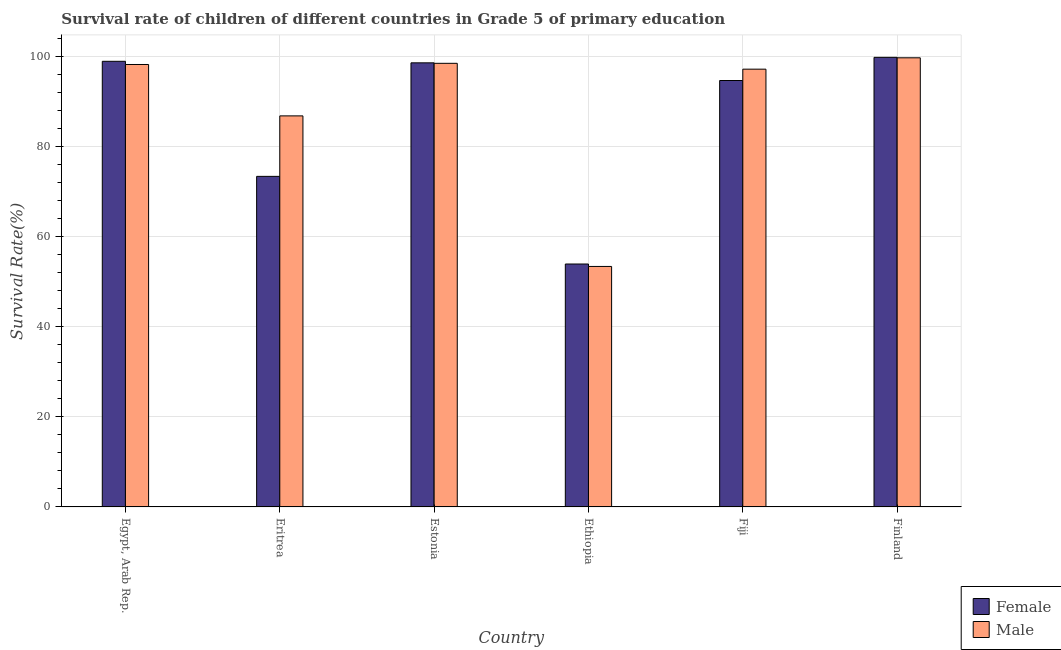How many different coloured bars are there?
Make the answer very short. 2. How many groups of bars are there?
Provide a short and direct response. 6. Are the number of bars per tick equal to the number of legend labels?
Your response must be concise. Yes. Are the number of bars on each tick of the X-axis equal?
Offer a very short reply. Yes. What is the survival rate of male students in primary education in Eritrea?
Ensure brevity in your answer.  86.85. Across all countries, what is the maximum survival rate of female students in primary education?
Your answer should be very brief. 99.85. Across all countries, what is the minimum survival rate of female students in primary education?
Give a very brief answer. 53.95. In which country was the survival rate of male students in primary education maximum?
Your response must be concise. Finland. In which country was the survival rate of female students in primary education minimum?
Give a very brief answer. Ethiopia. What is the total survival rate of female students in primary education in the graph?
Keep it short and to the point. 519.52. What is the difference between the survival rate of male students in primary education in Egypt, Arab Rep. and that in Fiji?
Provide a succinct answer. 1.04. What is the difference between the survival rate of male students in primary education in Finland and the survival rate of female students in primary education in Eritrea?
Offer a very short reply. 26.33. What is the average survival rate of female students in primary education per country?
Keep it short and to the point. 86.59. What is the difference between the survival rate of female students in primary education and survival rate of male students in primary education in Estonia?
Keep it short and to the point. 0.11. What is the ratio of the survival rate of male students in primary education in Estonia to that in Fiji?
Keep it short and to the point. 1.01. Is the difference between the survival rate of male students in primary education in Egypt, Arab Rep. and Eritrea greater than the difference between the survival rate of female students in primary education in Egypt, Arab Rep. and Eritrea?
Your response must be concise. No. What is the difference between the highest and the second highest survival rate of male students in primary education?
Offer a very short reply. 1.23. What is the difference between the highest and the lowest survival rate of male students in primary education?
Make the answer very short. 46.34. Is the sum of the survival rate of male students in primary education in Ethiopia and Fiji greater than the maximum survival rate of female students in primary education across all countries?
Give a very brief answer. Yes. What does the 1st bar from the left in Egypt, Arab Rep. represents?
Offer a very short reply. Female. How many bars are there?
Provide a short and direct response. 12. Are the values on the major ticks of Y-axis written in scientific E-notation?
Ensure brevity in your answer.  No. How many legend labels are there?
Keep it short and to the point. 2. How are the legend labels stacked?
Offer a terse response. Vertical. What is the title of the graph?
Keep it short and to the point. Survival rate of children of different countries in Grade 5 of primary education. What is the label or title of the Y-axis?
Ensure brevity in your answer.  Survival Rate(%). What is the Survival Rate(%) in Female in Egypt, Arab Rep.?
Offer a very short reply. 98.97. What is the Survival Rate(%) in Male in Egypt, Arab Rep.?
Offer a terse response. 98.26. What is the Survival Rate(%) in Female in Eritrea?
Provide a short and direct response. 73.41. What is the Survival Rate(%) of Male in Eritrea?
Provide a succinct answer. 86.85. What is the Survival Rate(%) in Female in Estonia?
Ensure brevity in your answer.  98.63. What is the Survival Rate(%) of Male in Estonia?
Provide a succinct answer. 98.52. What is the Survival Rate(%) in Female in Ethiopia?
Keep it short and to the point. 53.95. What is the Survival Rate(%) of Male in Ethiopia?
Ensure brevity in your answer.  53.41. What is the Survival Rate(%) in Female in Fiji?
Your answer should be compact. 94.71. What is the Survival Rate(%) of Male in Fiji?
Your response must be concise. 97.22. What is the Survival Rate(%) in Female in Finland?
Offer a terse response. 99.85. What is the Survival Rate(%) in Male in Finland?
Provide a succinct answer. 99.75. Across all countries, what is the maximum Survival Rate(%) in Female?
Offer a very short reply. 99.85. Across all countries, what is the maximum Survival Rate(%) of Male?
Offer a very short reply. 99.75. Across all countries, what is the minimum Survival Rate(%) in Female?
Your answer should be very brief. 53.95. Across all countries, what is the minimum Survival Rate(%) of Male?
Ensure brevity in your answer.  53.41. What is the total Survival Rate(%) of Female in the graph?
Provide a short and direct response. 519.52. What is the total Survival Rate(%) in Male in the graph?
Provide a succinct answer. 534.02. What is the difference between the Survival Rate(%) of Female in Egypt, Arab Rep. and that in Eritrea?
Your answer should be very brief. 25.55. What is the difference between the Survival Rate(%) in Male in Egypt, Arab Rep. and that in Eritrea?
Provide a succinct answer. 11.41. What is the difference between the Survival Rate(%) of Female in Egypt, Arab Rep. and that in Estonia?
Your answer should be compact. 0.34. What is the difference between the Survival Rate(%) in Male in Egypt, Arab Rep. and that in Estonia?
Keep it short and to the point. -0.26. What is the difference between the Survival Rate(%) of Female in Egypt, Arab Rep. and that in Ethiopia?
Your response must be concise. 45.02. What is the difference between the Survival Rate(%) of Male in Egypt, Arab Rep. and that in Ethiopia?
Your answer should be very brief. 44.85. What is the difference between the Survival Rate(%) in Female in Egypt, Arab Rep. and that in Fiji?
Provide a short and direct response. 4.26. What is the difference between the Survival Rate(%) of Male in Egypt, Arab Rep. and that in Fiji?
Give a very brief answer. 1.04. What is the difference between the Survival Rate(%) of Female in Egypt, Arab Rep. and that in Finland?
Your response must be concise. -0.88. What is the difference between the Survival Rate(%) in Male in Egypt, Arab Rep. and that in Finland?
Offer a terse response. -1.49. What is the difference between the Survival Rate(%) of Female in Eritrea and that in Estonia?
Provide a short and direct response. -25.22. What is the difference between the Survival Rate(%) in Male in Eritrea and that in Estonia?
Ensure brevity in your answer.  -11.67. What is the difference between the Survival Rate(%) of Female in Eritrea and that in Ethiopia?
Provide a succinct answer. 19.46. What is the difference between the Survival Rate(%) in Male in Eritrea and that in Ethiopia?
Ensure brevity in your answer.  33.44. What is the difference between the Survival Rate(%) in Female in Eritrea and that in Fiji?
Make the answer very short. -21.29. What is the difference between the Survival Rate(%) of Male in Eritrea and that in Fiji?
Offer a very short reply. -10.37. What is the difference between the Survival Rate(%) in Female in Eritrea and that in Finland?
Offer a terse response. -26.43. What is the difference between the Survival Rate(%) of Male in Eritrea and that in Finland?
Offer a very short reply. -12.9. What is the difference between the Survival Rate(%) of Female in Estonia and that in Ethiopia?
Your response must be concise. 44.68. What is the difference between the Survival Rate(%) in Male in Estonia and that in Ethiopia?
Your answer should be very brief. 45.11. What is the difference between the Survival Rate(%) in Female in Estonia and that in Fiji?
Your answer should be very brief. 3.92. What is the difference between the Survival Rate(%) of Male in Estonia and that in Fiji?
Give a very brief answer. 1.3. What is the difference between the Survival Rate(%) in Female in Estonia and that in Finland?
Give a very brief answer. -1.22. What is the difference between the Survival Rate(%) of Male in Estonia and that in Finland?
Provide a succinct answer. -1.23. What is the difference between the Survival Rate(%) in Female in Ethiopia and that in Fiji?
Your answer should be very brief. -40.75. What is the difference between the Survival Rate(%) of Male in Ethiopia and that in Fiji?
Offer a terse response. -43.81. What is the difference between the Survival Rate(%) in Female in Ethiopia and that in Finland?
Ensure brevity in your answer.  -45.9. What is the difference between the Survival Rate(%) of Male in Ethiopia and that in Finland?
Your response must be concise. -46.34. What is the difference between the Survival Rate(%) of Female in Fiji and that in Finland?
Provide a short and direct response. -5.14. What is the difference between the Survival Rate(%) in Male in Fiji and that in Finland?
Your response must be concise. -2.52. What is the difference between the Survival Rate(%) of Female in Egypt, Arab Rep. and the Survival Rate(%) of Male in Eritrea?
Your answer should be very brief. 12.12. What is the difference between the Survival Rate(%) of Female in Egypt, Arab Rep. and the Survival Rate(%) of Male in Estonia?
Provide a succinct answer. 0.44. What is the difference between the Survival Rate(%) in Female in Egypt, Arab Rep. and the Survival Rate(%) in Male in Ethiopia?
Your answer should be compact. 45.56. What is the difference between the Survival Rate(%) in Female in Egypt, Arab Rep. and the Survival Rate(%) in Male in Fiji?
Give a very brief answer. 1.74. What is the difference between the Survival Rate(%) in Female in Egypt, Arab Rep. and the Survival Rate(%) in Male in Finland?
Offer a terse response. -0.78. What is the difference between the Survival Rate(%) in Female in Eritrea and the Survival Rate(%) in Male in Estonia?
Ensure brevity in your answer.  -25.11. What is the difference between the Survival Rate(%) in Female in Eritrea and the Survival Rate(%) in Male in Ethiopia?
Give a very brief answer. 20. What is the difference between the Survival Rate(%) in Female in Eritrea and the Survival Rate(%) in Male in Fiji?
Provide a short and direct response. -23.81. What is the difference between the Survival Rate(%) in Female in Eritrea and the Survival Rate(%) in Male in Finland?
Make the answer very short. -26.34. What is the difference between the Survival Rate(%) of Female in Estonia and the Survival Rate(%) of Male in Ethiopia?
Ensure brevity in your answer.  45.22. What is the difference between the Survival Rate(%) in Female in Estonia and the Survival Rate(%) in Male in Fiji?
Offer a terse response. 1.41. What is the difference between the Survival Rate(%) of Female in Estonia and the Survival Rate(%) of Male in Finland?
Your answer should be compact. -1.12. What is the difference between the Survival Rate(%) in Female in Ethiopia and the Survival Rate(%) in Male in Fiji?
Give a very brief answer. -43.27. What is the difference between the Survival Rate(%) in Female in Ethiopia and the Survival Rate(%) in Male in Finland?
Provide a short and direct response. -45.8. What is the difference between the Survival Rate(%) of Female in Fiji and the Survival Rate(%) of Male in Finland?
Your answer should be compact. -5.04. What is the average Survival Rate(%) in Female per country?
Your answer should be compact. 86.59. What is the average Survival Rate(%) of Male per country?
Offer a terse response. 89. What is the difference between the Survival Rate(%) in Female and Survival Rate(%) in Male in Egypt, Arab Rep.?
Your response must be concise. 0.71. What is the difference between the Survival Rate(%) in Female and Survival Rate(%) in Male in Eritrea?
Ensure brevity in your answer.  -13.44. What is the difference between the Survival Rate(%) of Female and Survival Rate(%) of Male in Estonia?
Offer a terse response. 0.11. What is the difference between the Survival Rate(%) in Female and Survival Rate(%) in Male in Ethiopia?
Give a very brief answer. 0.54. What is the difference between the Survival Rate(%) of Female and Survival Rate(%) of Male in Fiji?
Offer a terse response. -2.52. What is the difference between the Survival Rate(%) in Female and Survival Rate(%) in Male in Finland?
Keep it short and to the point. 0.1. What is the ratio of the Survival Rate(%) in Female in Egypt, Arab Rep. to that in Eritrea?
Ensure brevity in your answer.  1.35. What is the ratio of the Survival Rate(%) in Male in Egypt, Arab Rep. to that in Eritrea?
Provide a succinct answer. 1.13. What is the ratio of the Survival Rate(%) in Female in Egypt, Arab Rep. to that in Estonia?
Your answer should be compact. 1. What is the ratio of the Survival Rate(%) of Male in Egypt, Arab Rep. to that in Estonia?
Offer a very short reply. 1. What is the ratio of the Survival Rate(%) of Female in Egypt, Arab Rep. to that in Ethiopia?
Offer a terse response. 1.83. What is the ratio of the Survival Rate(%) in Male in Egypt, Arab Rep. to that in Ethiopia?
Offer a terse response. 1.84. What is the ratio of the Survival Rate(%) in Female in Egypt, Arab Rep. to that in Fiji?
Offer a terse response. 1.04. What is the ratio of the Survival Rate(%) of Male in Egypt, Arab Rep. to that in Fiji?
Give a very brief answer. 1.01. What is the ratio of the Survival Rate(%) in Male in Egypt, Arab Rep. to that in Finland?
Your answer should be very brief. 0.99. What is the ratio of the Survival Rate(%) in Female in Eritrea to that in Estonia?
Offer a very short reply. 0.74. What is the ratio of the Survival Rate(%) of Male in Eritrea to that in Estonia?
Your answer should be very brief. 0.88. What is the ratio of the Survival Rate(%) of Female in Eritrea to that in Ethiopia?
Provide a succinct answer. 1.36. What is the ratio of the Survival Rate(%) in Male in Eritrea to that in Ethiopia?
Provide a succinct answer. 1.63. What is the ratio of the Survival Rate(%) of Female in Eritrea to that in Fiji?
Provide a short and direct response. 0.78. What is the ratio of the Survival Rate(%) in Male in Eritrea to that in Fiji?
Provide a short and direct response. 0.89. What is the ratio of the Survival Rate(%) in Female in Eritrea to that in Finland?
Give a very brief answer. 0.74. What is the ratio of the Survival Rate(%) of Male in Eritrea to that in Finland?
Make the answer very short. 0.87. What is the ratio of the Survival Rate(%) of Female in Estonia to that in Ethiopia?
Make the answer very short. 1.83. What is the ratio of the Survival Rate(%) in Male in Estonia to that in Ethiopia?
Make the answer very short. 1.84. What is the ratio of the Survival Rate(%) in Female in Estonia to that in Fiji?
Give a very brief answer. 1.04. What is the ratio of the Survival Rate(%) of Male in Estonia to that in Fiji?
Offer a very short reply. 1.01. What is the ratio of the Survival Rate(%) of Female in Ethiopia to that in Fiji?
Ensure brevity in your answer.  0.57. What is the ratio of the Survival Rate(%) in Male in Ethiopia to that in Fiji?
Provide a succinct answer. 0.55. What is the ratio of the Survival Rate(%) in Female in Ethiopia to that in Finland?
Your answer should be compact. 0.54. What is the ratio of the Survival Rate(%) of Male in Ethiopia to that in Finland?
Keep it short and to the point. 0.54. What is the ratio of the Survival Rate(%) in Female in Fiji to that in Finland?
Give a very brief answer. 0.95. What is the ratio of the Survival Rate(%) of Male in Fiji to that in Finland?
Offer a very short reply. 0.97. What is the difference between the highest and the second highest Survival Rate(%) in Female?
Ensure brevity in your answer.  0.88. What is the difference between the highest and the second highest Survival Rate(%) in Male?
Keep it short and to the point. 1.23. What is the difference between the highest and the lowest Survival Rate(%) in Female?
Your response must be concise. 45.9. What is the difference between the highest and the lowest Survival Rate(%) in Male?
Provide a succinct answer. 46.34. 